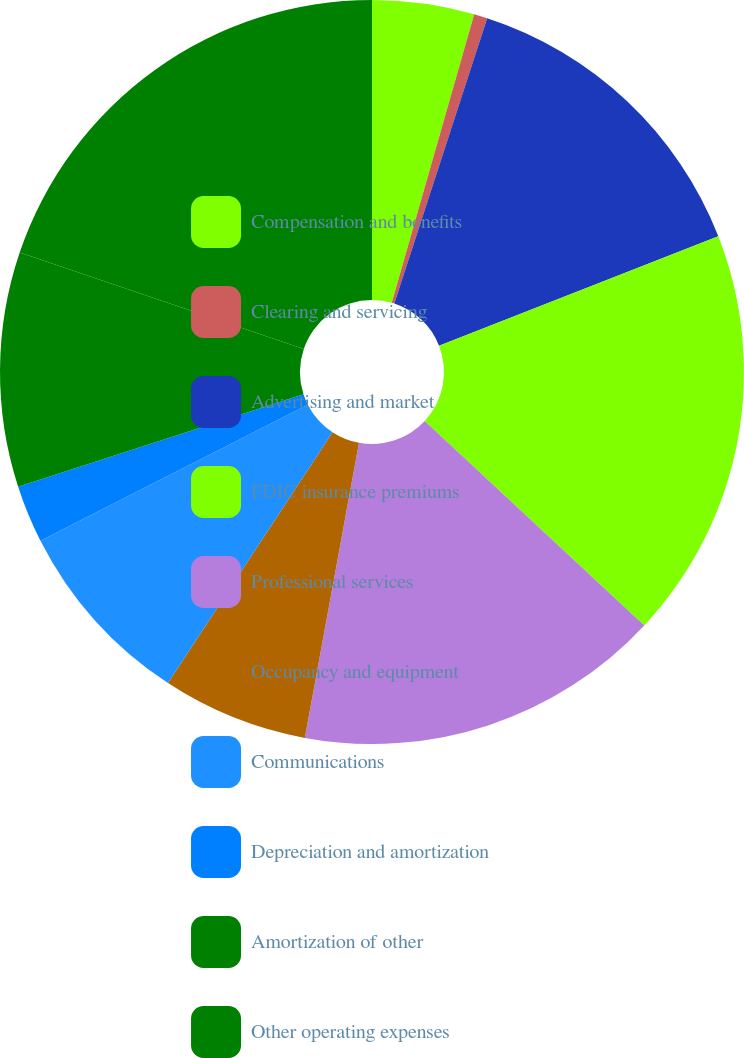Convert chart. <chart><loc_0><loc_0><loc_500><loc_500><pie_chart><fcel>Compensation and benefits<fcel>Clearing and servicing<fcel>Advertising and market<fcel>FDIC insurance premiums<fcel>Professional services<fcel>Occupancy and equipment<fcel>Communications<fcel>Depreciation and amortization<fcel>Amortization of other<fcel>Other operating expenses<nl><fcel>4.43%<fcel>0.58%<fcel>14.04%<fcel>17.88%<fcel>15.96%<fcel>6.35%<fcel>8.27%<fcel>2.5%<fcel>10.19%<fcel>19.8%<nl></chart> 